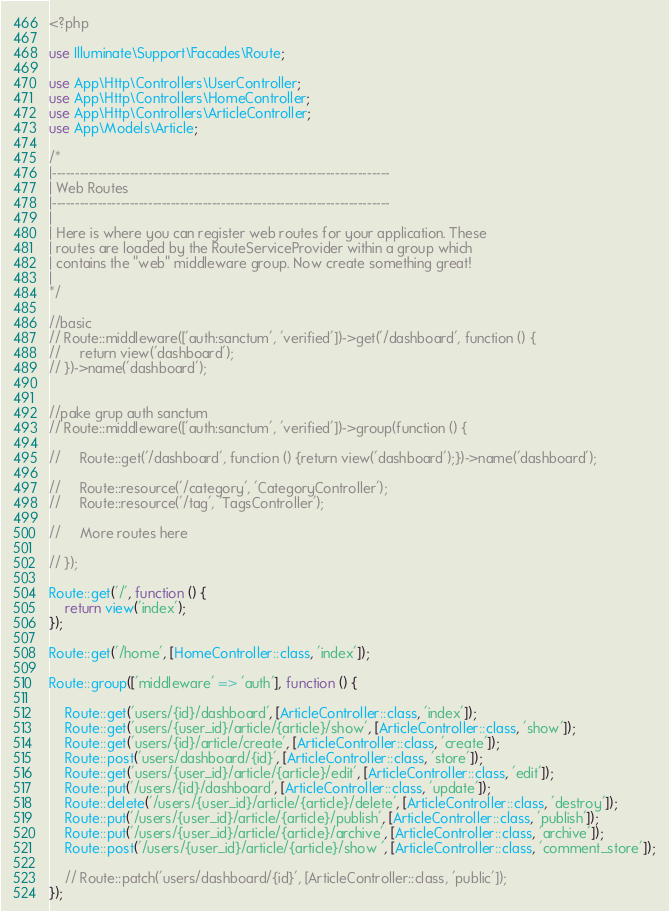<code> <loc_0><loc_0><loc_500><loc_500><_PHP_><?php

use Illuminate\Support\Facades\Route;

use App\Http\Controllers\UserController;
use App\Http\Controllers\HomeController;
use App\Http\Controllers\ArticleController;
use App\Models\Article;

/*
|--------------------------------------------------------------------------
| Web Routes
|--------------------------------------------------------------------------
|
| Here is where you can register web routes for your application. These
| routes are loaded by the RouteServiceProvider within a group which
| contains the "web" middleware group. Now create something great!
|
*/

//basic
// Route::middleware(['auth:sanctum', 'verified'])->get('/dashboard', function () {
//     return view('dashboard');
// })->name('dashboard');


//pake grup auth sanctum
// Route::middleware(['auth:sanctum', 'verified'])->group(function () {

//     Route::get('/dashboard', function () {return view('dashboard');})->name('dashboard');

//     Route::resource('/category', 'CategoryController');
//     Route::resource('/tag', 'TagsController');

//     More routes here

// });

Route::get('/', function () {
    return view('index');
});

Route::get('/home', [HomeController::class, 'index']);

Route::group(['middleware' => 'auth'], function () {

    Route::get('users/{id}/dashboard', [ArticleController::class, 'index']);
    Route::get('users/{user_id}/article/{article}/show', [ArticleController::class, 'show']);
    Route::get('users/{id}/article/create', [ArticleController::class, 'create']);
    Route::post('users/dashboard/{id}', [ArticleController::class, 'store']);
    Route::get('users/{user_id}/article/{article}/edit', [ArticleController::class, 'edit']);
    Route::put('/users/{id}/dashboard', [ArticleController::class, 'update']);
    Route::delete('/users/{user_id}/article/{article}/delete', [ArticleController::class, 'destroy']);
    Route::put('/users/{user_id}/article/{article}/publish', [ArticleController::class, 'publish']);
    Route::put('/users/{user_id}/article/{article}/archive', [ArticleController::class, 'archive']);
    Route::post('/users/{user_id}/article/{article}/show ', [ArticleController::class, 'comment_store']);

    // Route::patch('users/dashboard/{id}', [ArticleController::class, 'public']);
});
</code> 